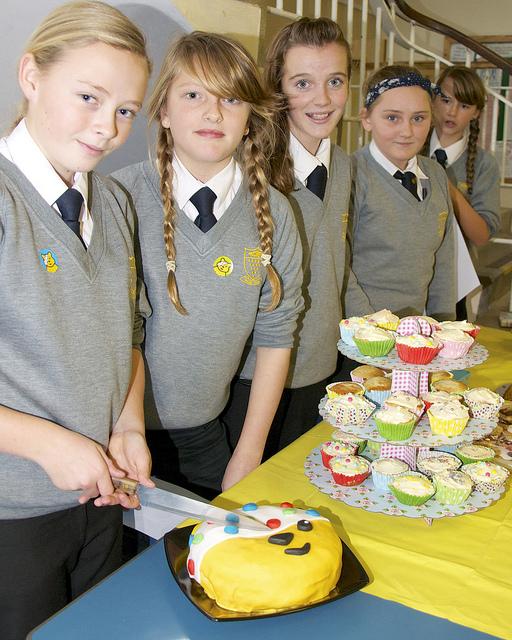Are the children from a public school?
Give a very brief answer. No. What is the blue object wrapped around the boy's head?
Concise answer only. Bandana. Are the people cutting a cake?
Keep it brief. Yes. 